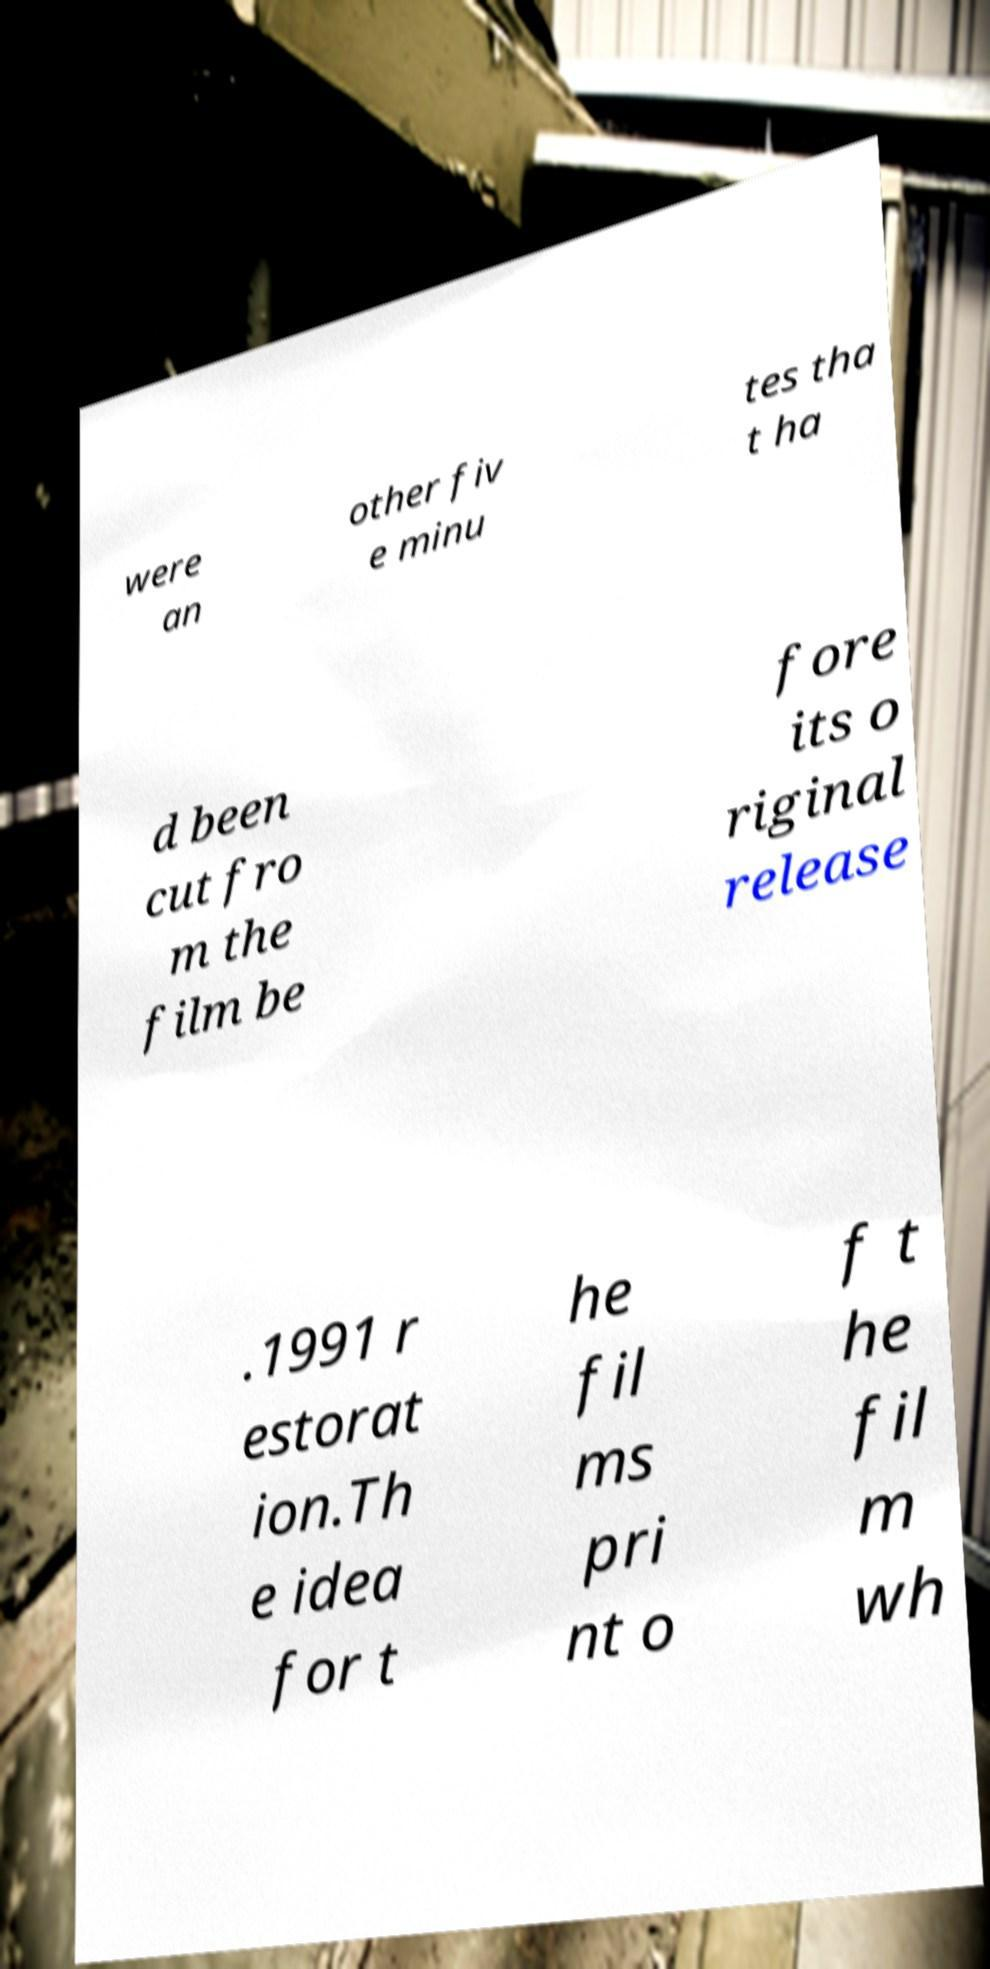For documentation purposes, I need the text within this image transcribed. Could you provide that? were an other fiv e minu tes tha t ha d been cut fro m the film be fore its o riginal release .1991 r estorat ion.Th e idea for t he fil ms pri nt o f t he fil m wh 